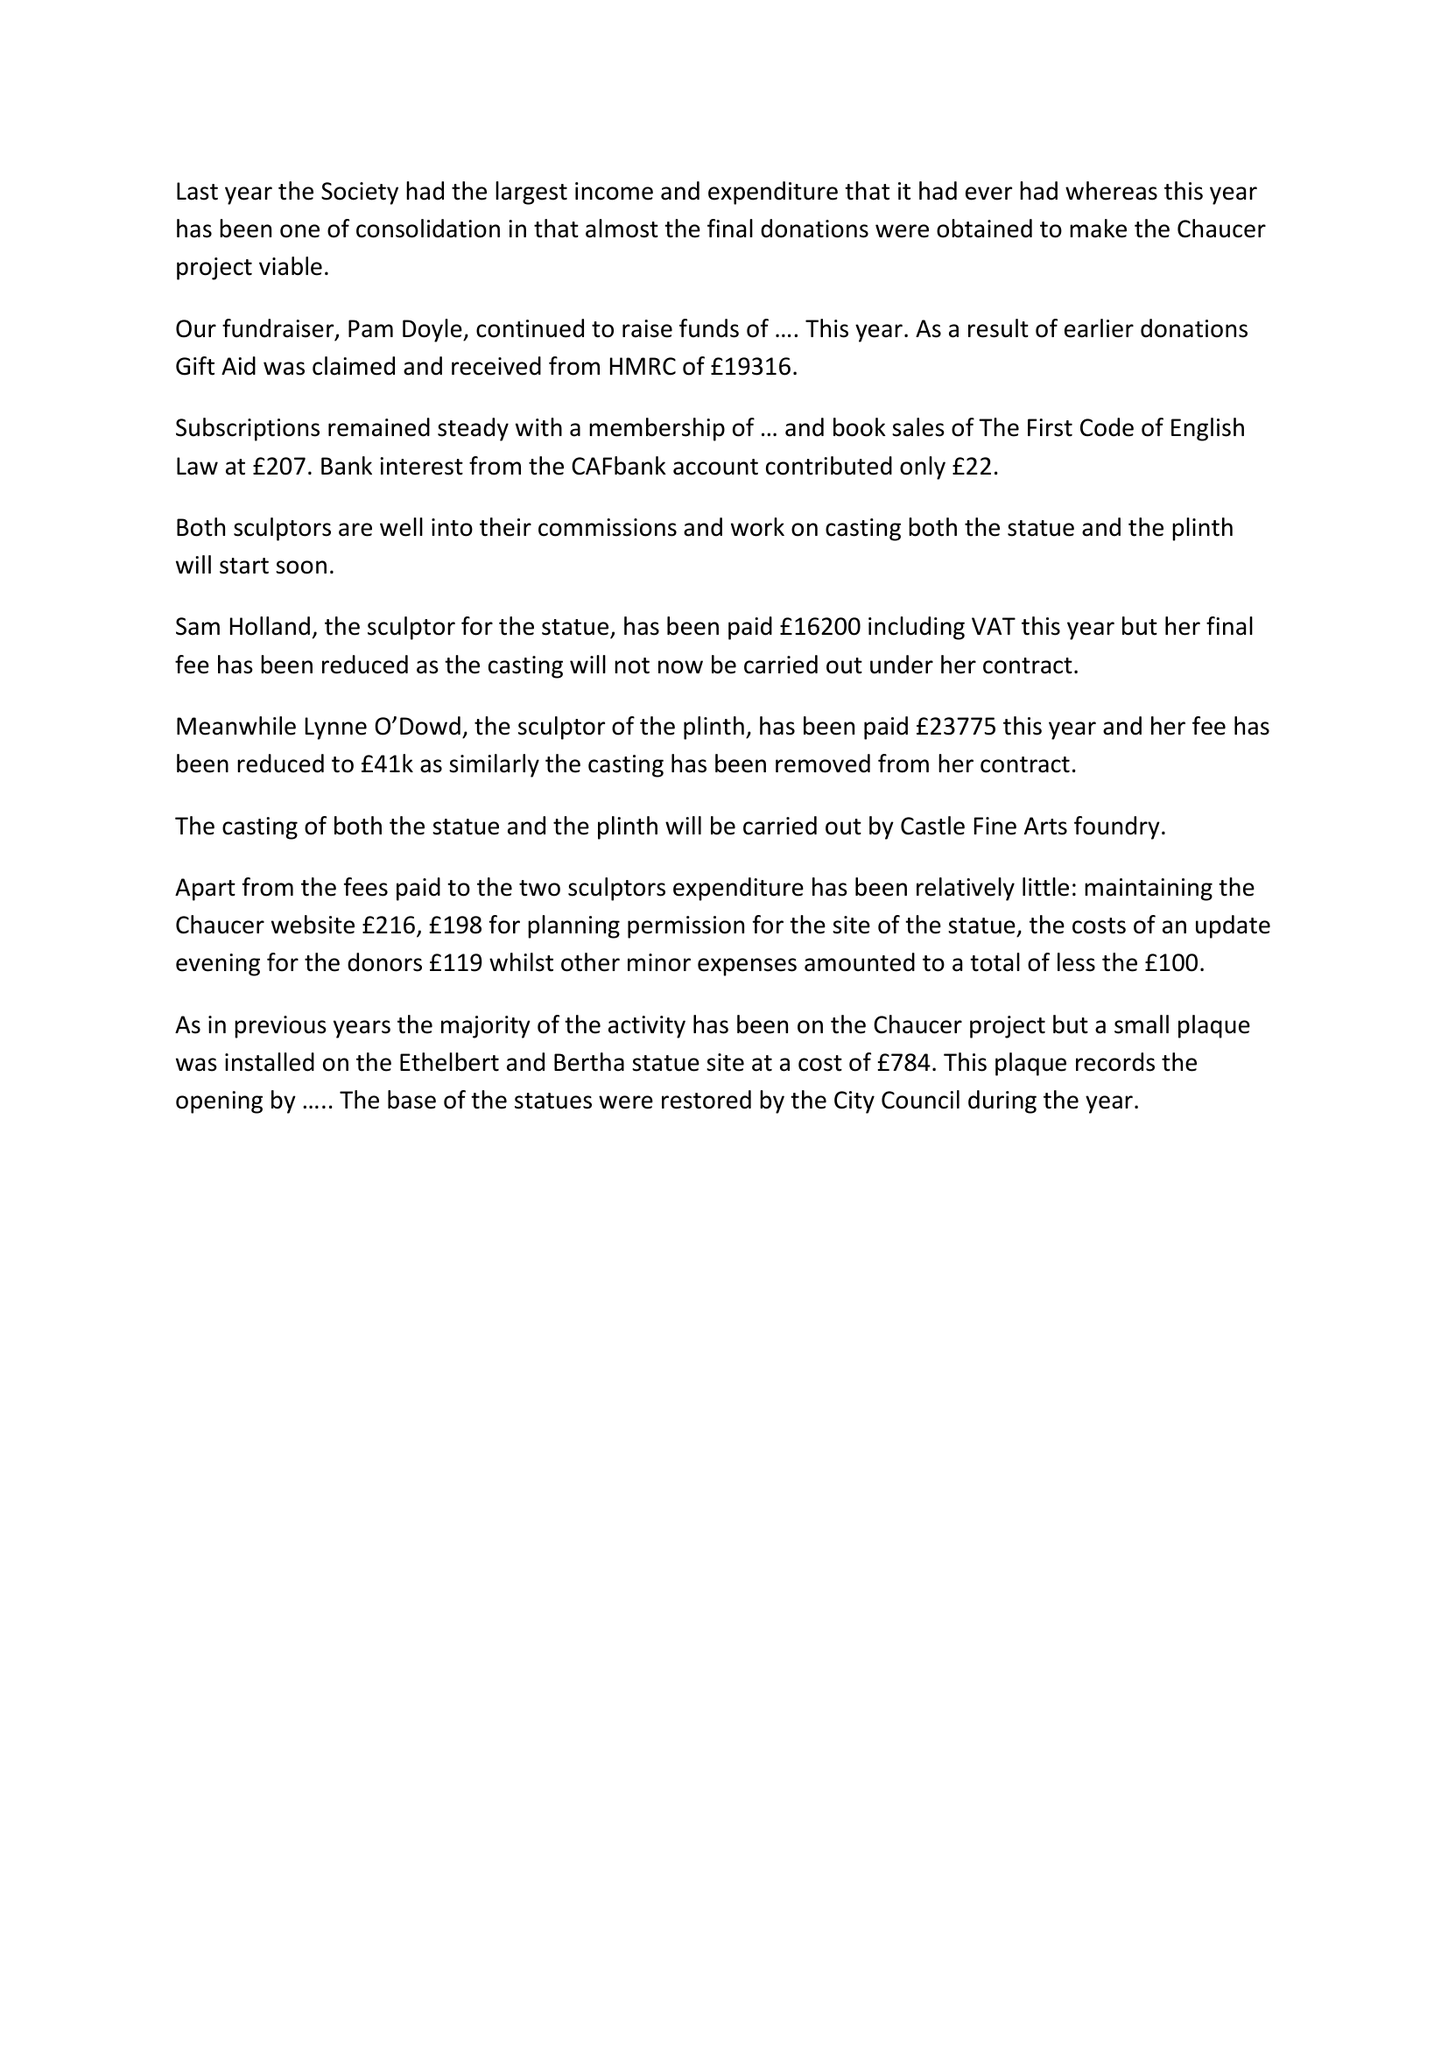What is the value for the address__post_town?
Answer the question using a single word or phrase. None 